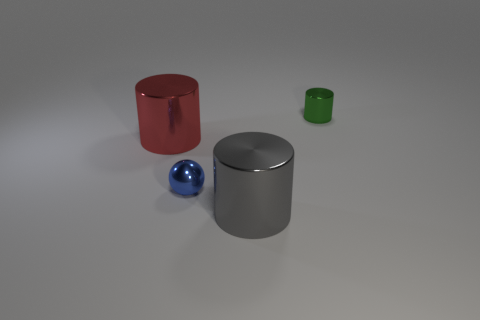If these objects were part of an educational toy, what might be the purpose of each color and shape? As part of an educational toy, each object could serve to teach different concepts: the red cylinder might be for learning about geometry and spatial awareness, the silver cylinder could be used to teach about materials and reflection, the blue sphere could be a lesson in colors and contrasts, while the green cylinder might tie into a lesson on size comparison and proportions. 